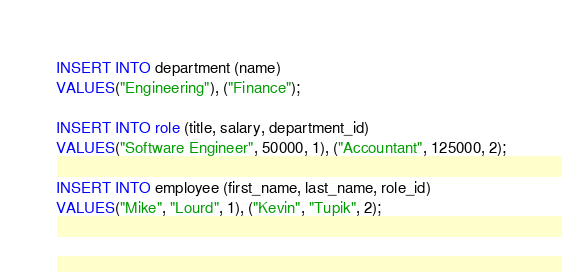Convert code to text. <code><loc_0><loc_0><loc_500><loc_500><_SQL_>
INSERT INTO department (name)
VALUES("Engineering"), ("Finance");

INSERT INTO role (title, salary, department_id)
VALUES("Software Engineer", 50000, 1), ("Accountant", 125000, 2);

INSERT INTO employee (first_name, last_name, role_id)
VALUES("Mike", "Lourd", 1), ("Kevin", "Tupik", 2);</code> 